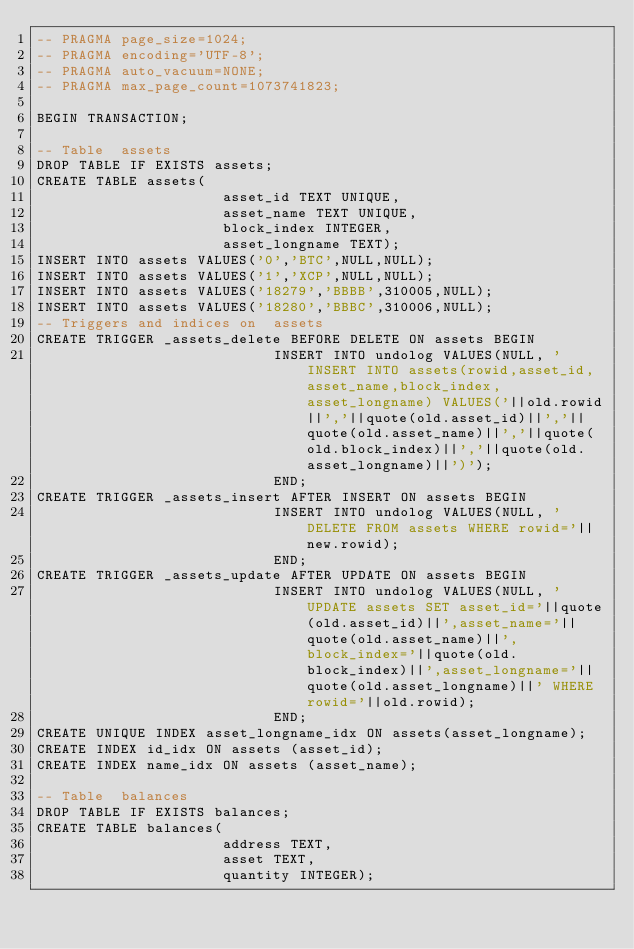<code> <loc_0><loc_0><loc_500><loc_500><_SQL_>-- PRAGMA page_size=1024;
-- PRAGMA encoding='UTF-8';
-- PRAGMA auto_vacuum=NONE;
-- PRAGMA max_page_count=1073741823;

BEGIN TRANSACTION;

-- Table  assets
DROP TABLE IF EXISTS assets;
CREATE TABLE assets(
                      asset_id TEXT UNIQUE,
                      asset_name TEXT UNIQUE,
                      block_index INTEGER,
                      asset_longname TEXT);
INSERT INTO assets VALUES('0','BTC',NULL,NULL);
INSERT INTO assets VALUES('1','XCP',NULL,NULL);
INSERT INTO assets VALUES('18279','BBBB',310005,NULL);
INSERT INTO assets VALUES('18280','BBBC',310006,NULL);
-- Triggers and indices on  assets
CREATE TRIGGER _assets_delete BEFORE DELETE ON assets BEGIN
                            INSERT INTO undolog VALUES(NULL, 'INSERT INTO assets(rowid,asset_id,asset_name,block_index,asset_longname) VALUES('||old.rowid||','||quote(old.asset_id)||','||quote(old.asset_name)||','||quote(old.block_index)||','||quote(old.asset_longname)||')');
                            END;
CREATE TRIGGER _assets_insert AFTER INSERT ON assets BEGIN
                            INSERT INTO undolog VALUES(NULL, 'DELETE FROM assets WHERE rowid='||new.rowid);
                            END;
CREATE TRIGGER _assets_update AFTER UPDATE ON assets BEGIN
                            INSERT INTO undolog VALUES(NULL, 'UPDATE assets SET asset_id='||quote(old.asset_id)||',asset_name='||quote(old.asset_name)||',block_index='||quote(old.block_index)||',asset_longname='||quote(old.asset_longname)||' WHERE rowid='||old.rowid);
                            END;
CREATE UNIQUE INDEX asset_longname_idx ON assets(asset_longname);
CREATE INDEX id_idx ON assets (asset_id);
CREATE INDEX name_idx ON assets (asset_name);

-- Table  balances
DROP TABLE IF EXISTS balances;
CREATE TABLE balances(
                      address TEXT,
                      asset TEXT,
                      quantity INTEGER);</code> 